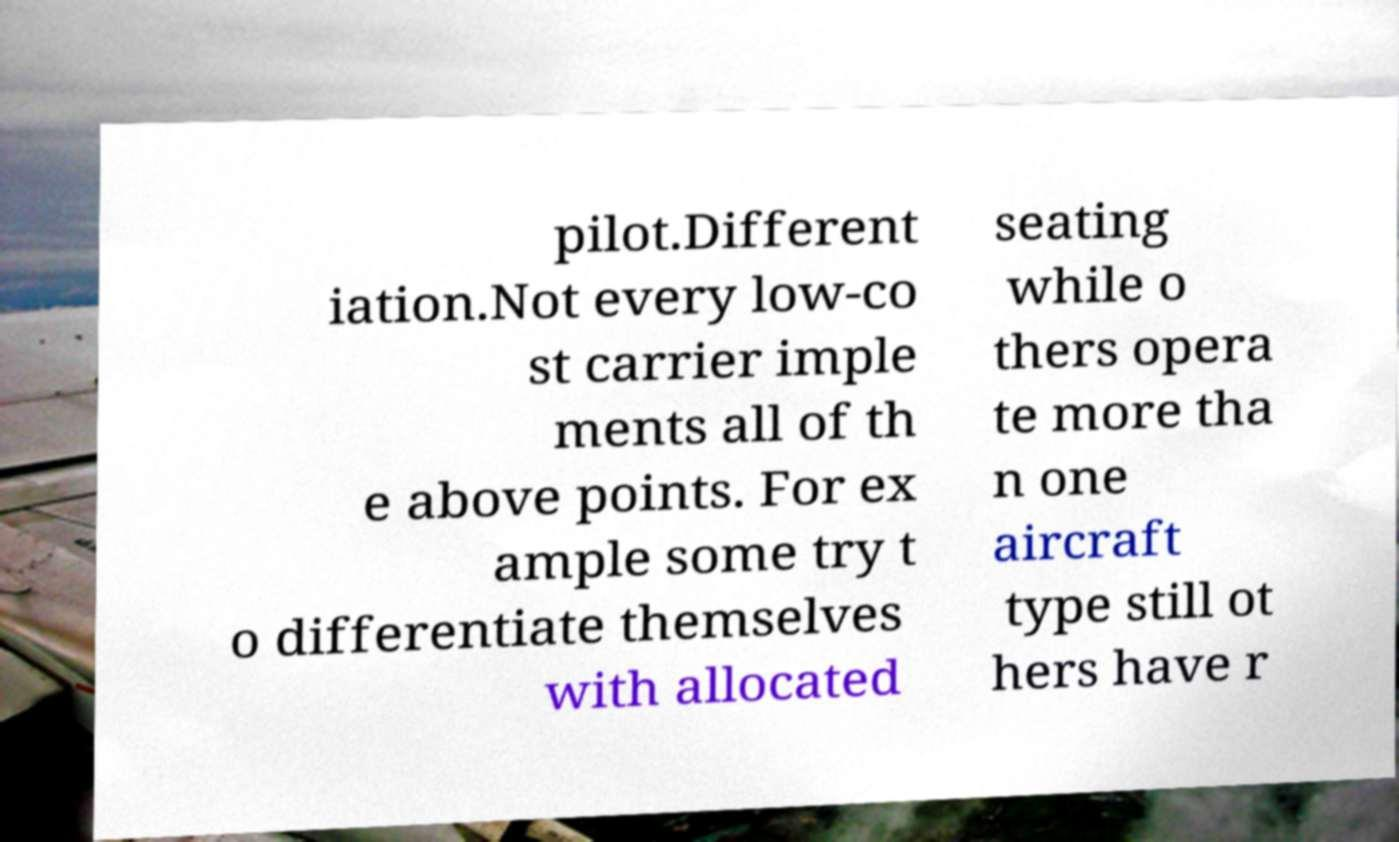Please read and relay the text visible in this image. What does it say? pilot.Different iation.Not every low-co st carrier imple ments all of th e above points. For ex ample some try t o differentiate themselves with allocated seating while o thers opera te more tha n one aircraft type still ot hers have r 